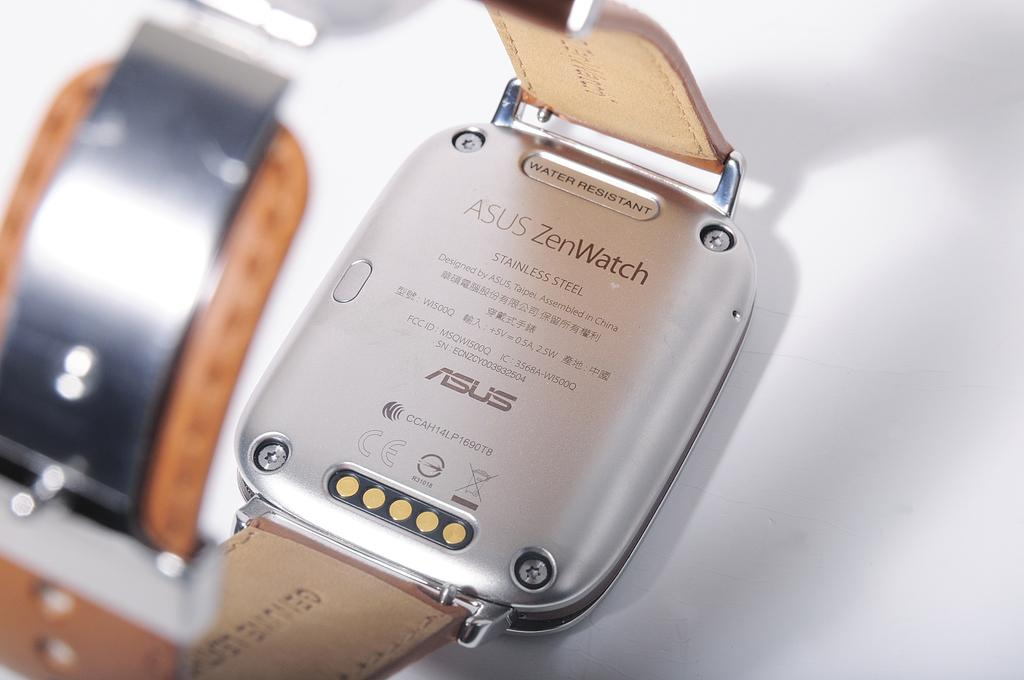<image>
Offer a succinct explanation of the picture presented. a watch and the brand is asus watch 